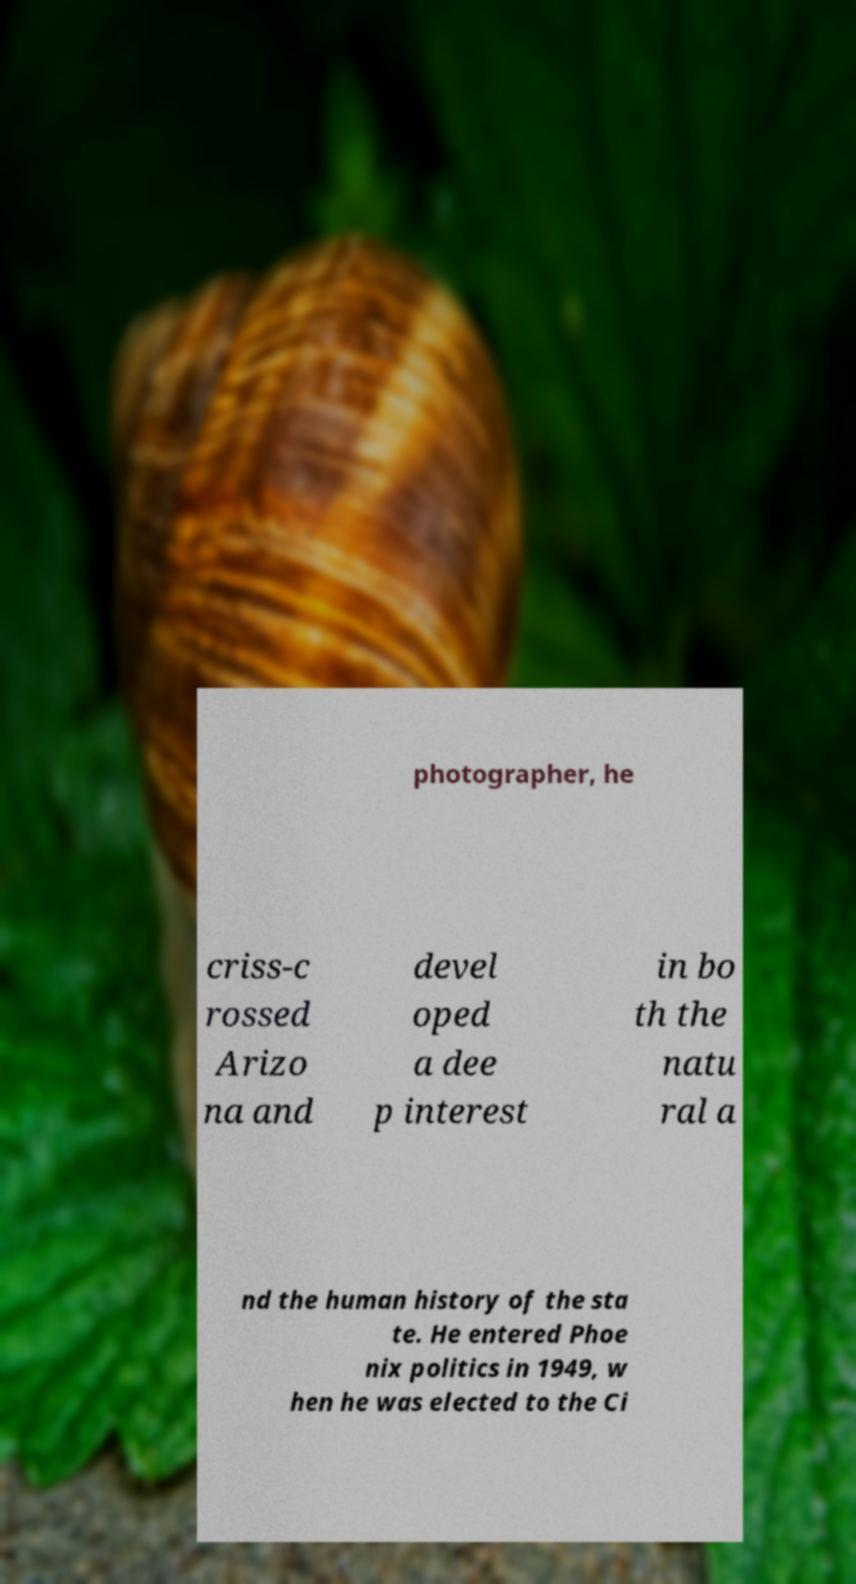Could you assist in decoding the text presented in this image and type it out clearly? photographer, he criss-c rossed Arizo na and devel oped a dee p interest in bo th the natu ral a nd the human history of the sta te. He entered Phoe nix politics in 1949, w hen he was elected to the Ci 